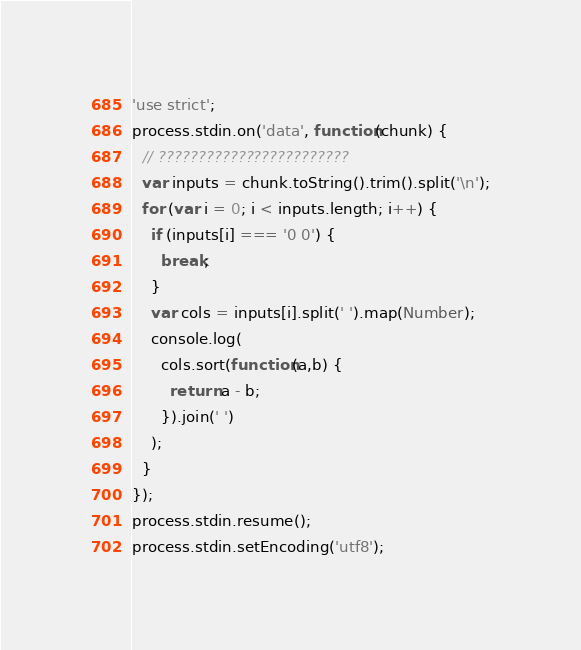<code> <loc_0><loc_0><loc_500><loc_500><_JavaScript_>'use strict';
process.stdin.on('data', function(chunk) {
  // ????????????????????????
  var inputs = chunk.toString().trim().split('\n');
  for (var i = 0; i < inputs.length; i++) {
    if (inputs[i] === '0 0') {
      break;
    }
    var cols = inputs[i].split(' ').map(Number);
    console.log(
      cols.sort(function(a,b) {
        return a - b;
      }).join(' ')
    );
  }
});
process.stdin.resume();
process.stdin.setEncoding('utf8');</code> 